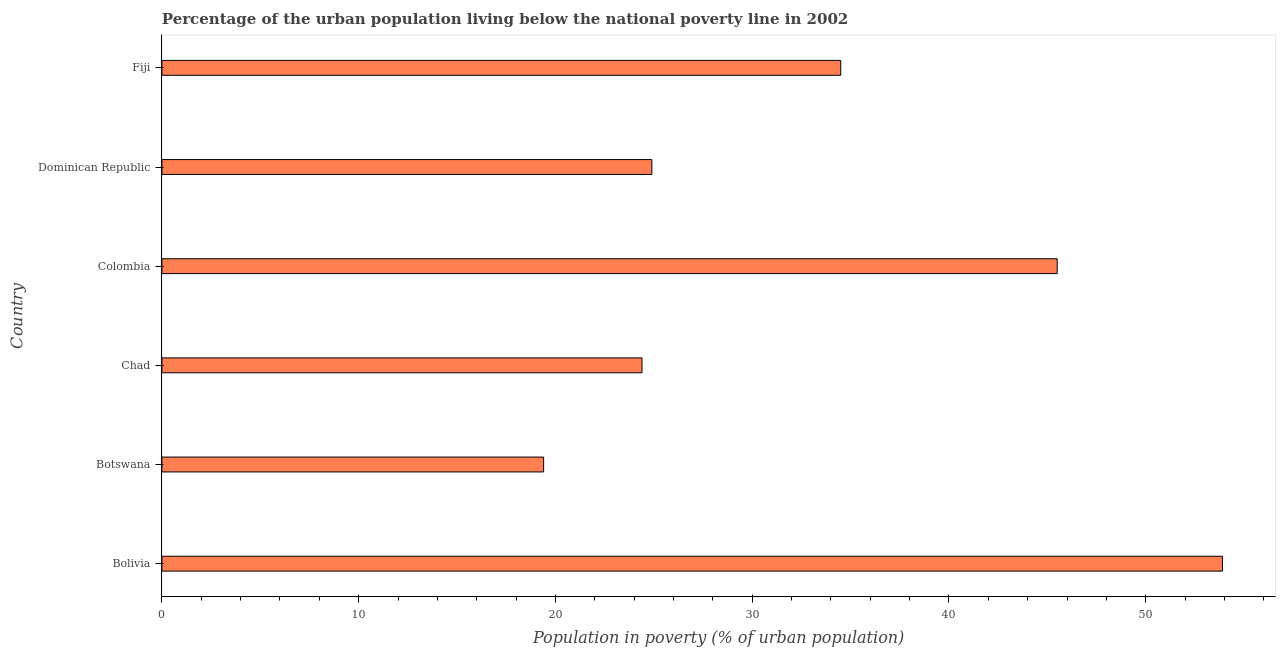Does the graph contain any zero values?
Keep it short and to the point. No. Does the graph contain grids?
Give a very brief answer. No. What is the title of the graph?
Your response must be concise. Percentage of the urban population living below the national poverty line in 2002. What is the label or title of the X-axis?
Provide a short and direct response. Population in poverty (% of urban population). What is the percentage of urban population living below poverty line in Dominican Republic?
Keep it short and to the point. 24.9. Across all countries, what is the maximum percentage of urban population living below poverty line?
Your answer should be compact. 53.9. In which country was the percentage of urban population living below poverty line minimum?
Your answer should be very brief. Botswana. What is the sum of the percentage of urban population living below poverty line?
Keep it short and to the point. 202.6. What is the difference between the percentage of urban population living below poverty line in Colombia and Dominican Republic?
Your response must be concise. 20.6. What is the average percentage of urban population living below poverty line per country?
Your answer should be very brief. 33.77. What is the median percentage of urban population living below poverty line?
Ensure brevity in your answer.  29.7. In how many countries, is the percentage of urban population living below poverty line greater than 46 %?
Ensure brevity in your answer.  1. What is the ratio of the percentage of urban population living below poverty line in Bolivia to that in Colombia?
Offer a very short reply. 1.19. What is the difference between the highest and the lowest percentage of urban population living below poverty line?
Offer a very short reply. 34.5. In how many countries, is the percentage of urban population living below poverty line greater than the average percentage of urban population living below poverty line taken over all countries?
Your response must be concise. 3. Are the values on the major ticks of X-axis written in scientific E-notation?
Ensure brevity in your answer.  No. What is the Population in poverty (% of urban population) in Bolivia?
Offer a very short reply. 53.9. What is the Population in poverty (% of urban population) in Botswana?
Offer a terse response. 19.4. What is the Population in poverty (% of urban population) in Chad?
Provide a succinct answer. 24.4. What is the Population in poverty (% of urban population) in Colombia?
Ensure brevity in your answer.  45.5. What is the Population in poverty (% of urban population) in Dominican Republic?
Ensure brevity in your answer.  24.9. What is the Population in poverty (% of urban population) of Fiji?
Ensure brevity in your answer.  34.5. What is the difference between the Population in poverty (% of urban population) in Bolivia and Botswana?
Provide a short and direct response. 34.5. What is the difference between the Population in poverty (% of urban population) in Bolivia and Chad?
Your answer should be compact. 29.5. What is the difference between the Population in poverty (% of urban population) in Bolivia and Colombia?
Keep it short and to the point. 8.4. What is the difference between the Population in poverty (% of urban population) in Botswana and Colombia?
Give a very brief answer. -26.1. What is the difference between the Population in poverty (% of urban population) in Botswana and Fiji?
Ensure brevity in your answer.  -15.1. What is the difference between the Population in poverty (% of urban population) in Chad and Colombia?
Your answer should be compact. -21.1. What is the difference between the Population in poverty (% of urban population) in Colombia and Dominican Republic?
Your answer should be compact. 20.6. What is the difference between the Population in poverty (% of urban population) in Colombia and Fiji?
Ensure brevity in your answer.  11. What is the difference between the Population in poverty (% of urban population) in Dominican Republic and Fiji?
Your response must be concise. -9.6. What is the ratio of the Population in poverty (% of urban population) in Bolivia to that in Botswana?
Provide a short and direct response. 2.78. What is the ratio of the Population in poverty (% of urban population) in Bolivia to that in Chad?
Your answer should be very brief. 2.21. What is the ratio of the Population in poverty (% of urban population) in Bolivia to that in Colombia?
Give a very brief answer. 1.19. What is the ratio of the Population in poverty (% of urban population) in Bolivia to that in Dominican Republic?
Offer a terse response. 2.17. What is the ratio of the Population in poverty (% of urban population) in Bolivia to that in Fiji?
Make the answer very short. 1.56. What is the ratio of the Population in poverty (% of urban population) in Botswana to that in Chad?
Offer a terse response. 0.8. What is the ratio of the Population in poverty (% of urban population) in Botswana to that in Colombia?
Your answer should be compact. 0.43. What is the ratio of the Population in poverty (% of urban population) in Botswana to that in Dominican Republic?
Give a very brief answer. 0.78. What is the ratio of the Population in poverty (% of urban population) in Botswana to that in Fiji?
Your answer should be compact. 0.56. What is the ratio of the Population in poverty (% of urban population) in Chad to that in Colombia?
Your answer should be very brief. 0.54. What is the ratio of the Population in poverty (% of urban population) in Chad to that in Fiji?
Your response must be concise. 0.71. What is the ratio of the Population in poverty (% of urban population) in Colombia to that in Dominican Republic?
Give a very brief answer. 1.83. What is the ratio of the Population in poverty (% of urban population) in Colombia to that in Fiji?
Provide a short and direct response. 1.32. What is the ratio of the Population in poverty (% of urban population) in Dominican Republic to that in Fiji?
Keep it short and to the point. 0.72. 